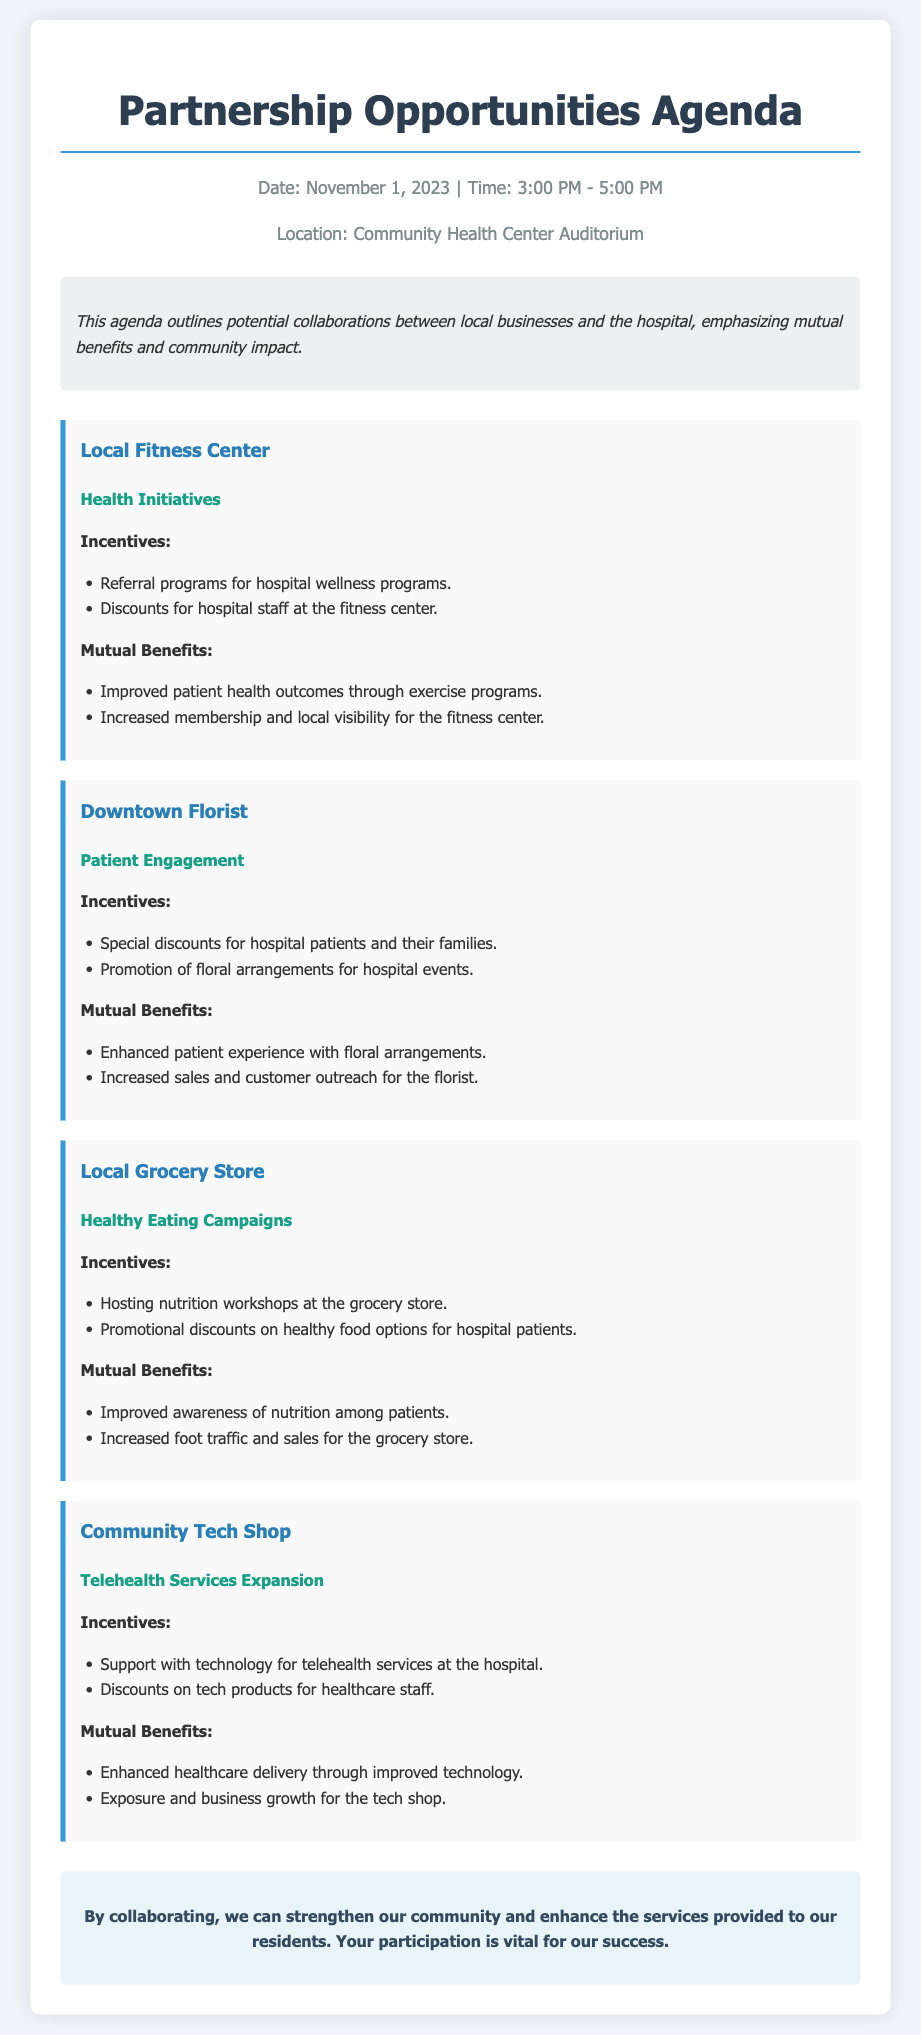What is the date of the agenda? The date of the agenda is clearly stated at the beginning of the document.
Answer: November 1, 2023 What is the location of the event? The location is mentioned in the header information section of the document.
Answer: Community Health Center Auditorium What is one incentive offered by the Local Fitness Center? The document lists specific incentives under each partnership.
Answer: Referral programs for hospital wellness programs What mutual benefit is associated with the Downtown Florist? The document explains the benefits of each partnership, including those for local businesses.
Answer: Increased sales and customer outreach for the florist What type of campaign is associated with the Local Grocery Store? The type of campaign is outlined in the partnership section of the document.
Answer: Healthy Eating Campaigns How long is the meeting scheduled to last? The duration is provided in the header information of the document, detailing the start and end time.
Answer: 2 hours What technology-related support is offered by the Community Tech Shop? The document specifies the type of support for telehealth services provided by the tech shop.
Answer: Support with technology for telehealth services at the hospital What is emphasized as vital for success in the closing remarks? The closing remarks highlight the importance of participation in collaborative efforts.
Answer: Your participation 